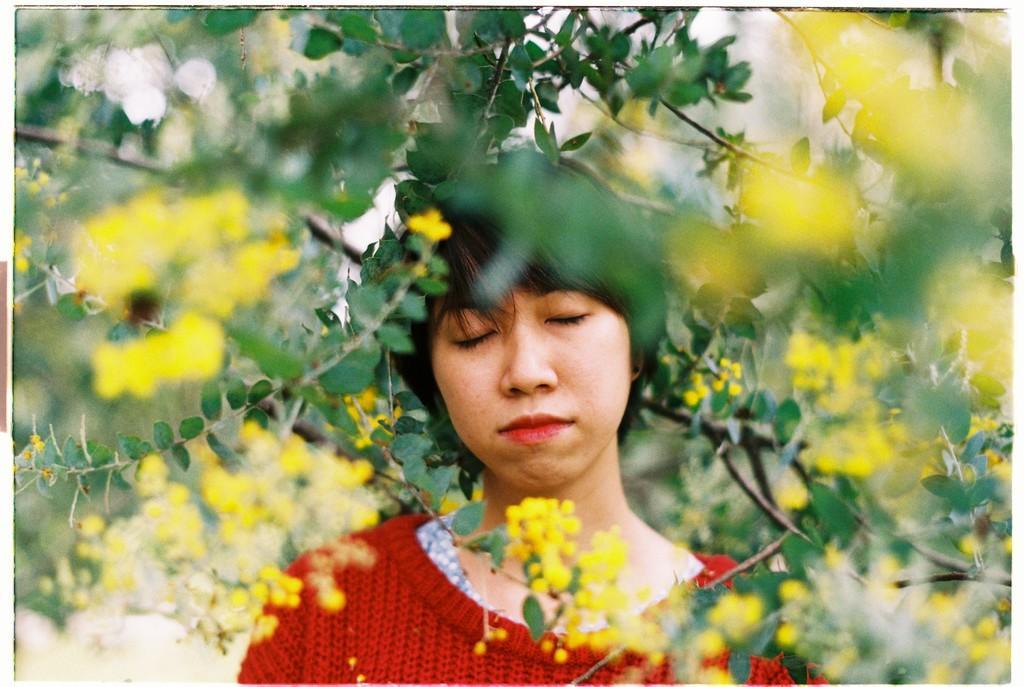How would you summarize this image in a sentence or two? in this picture we can see a woman standing and closing her eyes wearing a red color t shirt and i can see trees , flowers. 